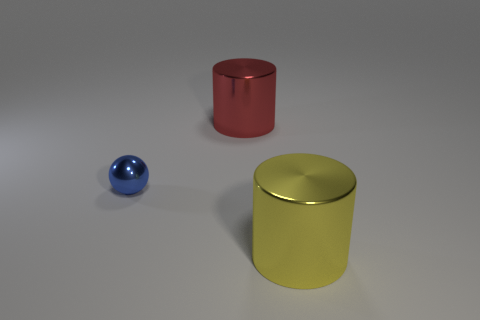Add 2 brown cylinders. How many objects exist? 5 Subtract all balls. How many objects are left? 2 Add 1 cyan objects. How many cyan objects exist? 1 Subtract 0 green cylinders. How many objects are left? 3 Subtract all large things. Subtract all red metallic cylinders. How many objects are left? 0 Add 2 red shiny cylinders. How many red shiny cylinders are left? 3 